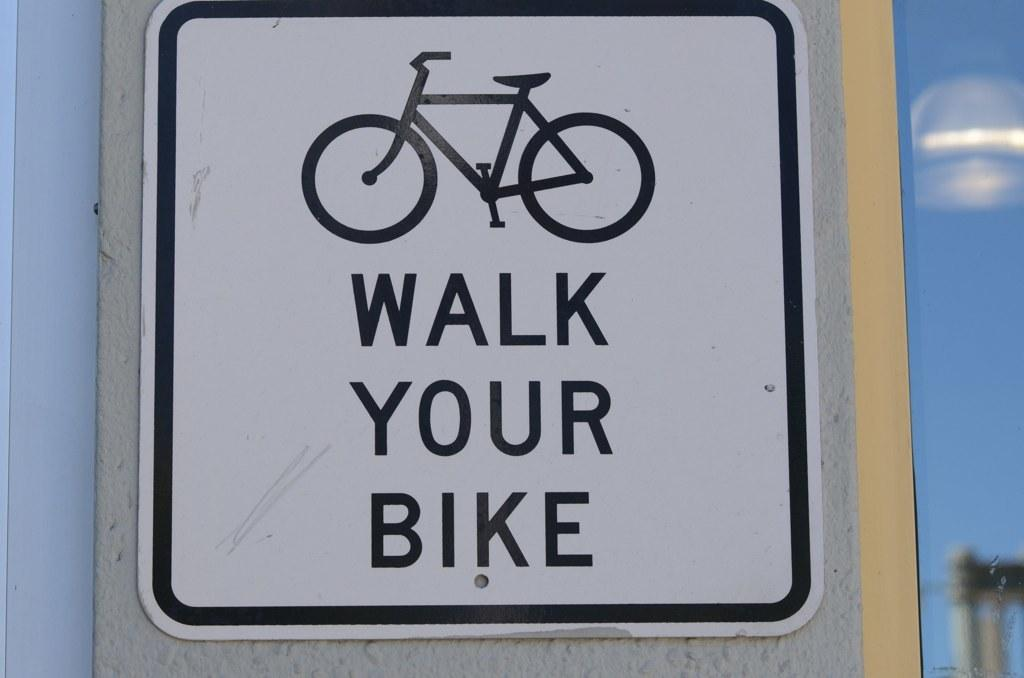What is the main object in the image? There is a sign board in the image. What can be seen on the sign board? The sign board has an image and text on it. Is there a wheel attached to the sign board in the image? No, there is no wheel attached to the sign board in the image. 